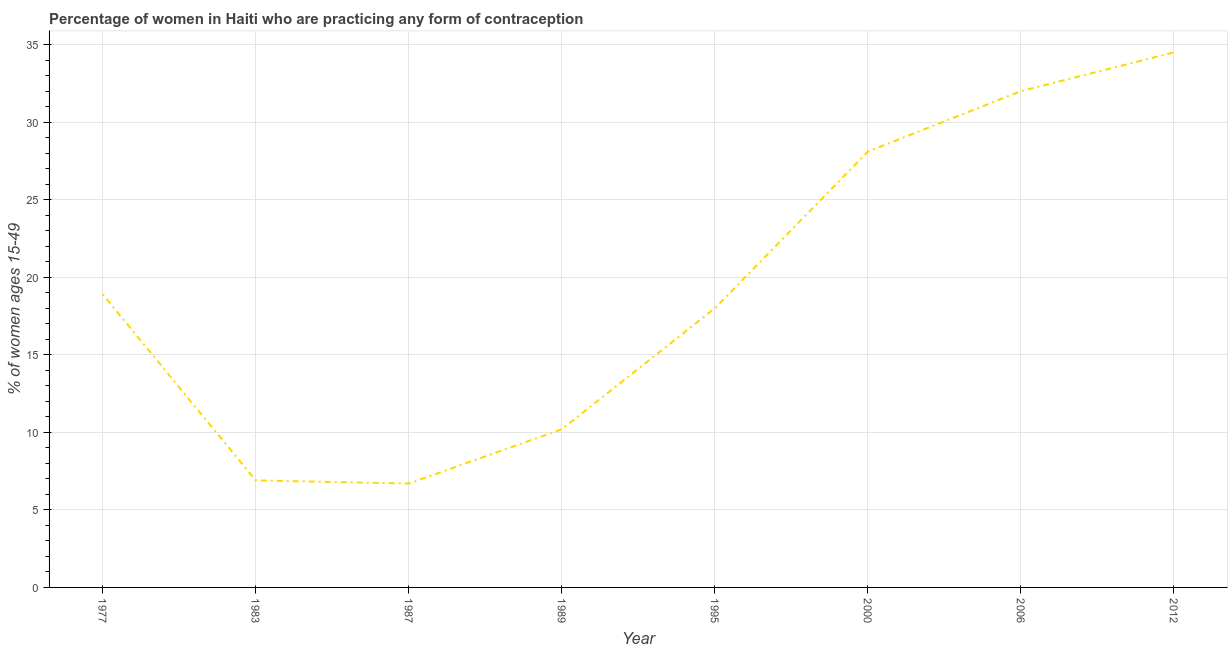What is the contraceptive prevalence in 2000?
Your answer should be compact. 28.1. Across all years, what is the maximum contraceptive prevalence?
Your response must be concise. 34.5. Across all years, what is the minimum contraceptive prevalence?
Your response must be concise. 6.7. In which year was the contraceptive prevalence maximum?
Your response must be concise. 2012. What is the sum of the contraceptive prevalence?
Keep it short and to the point. 155.3. What is the difference between the contraceptive prevalence in 1989 and 2006?
Give a very brief answer. -21.8. What is the average contraceptive prevalence per year?
Your answer should be very brief. 19.41. What is the median contraceptive prevalence?
Your answer should be very brief. 18.45. What is the ratio of the contraceptive prevalence in 1983 to that in 2006?
Provide a succinct answer. 0.22. Is the difference between the contraceptive prevalence in 1989 and 1995 greater than the difference between any two years?
Your answer should be very brief. No. Is the sum of the contraceptive prevalence in 1977 and 1989 greater than the maximum contraceptive prevalence across all years?
Keep it short and to the point. No. What is the difference between the highest and the lowest contraceptive prevalence?
Keep it short and to the point. 27.8. How many lines are there?
Ensure brevity in your answer.  1. Are the values on the major ticks of Y-axis written in scientific E-notation?
Your response must be concise. No. Does the graph contain grids?
Your response must be concise. Yes. What is the title of the graph?
Provide a succinct answer. Percentage of women in Haiti who are practicing any form of contraception. What is the label or title of the X-axis?
Provide a succinct answer. Year. What is the label or title of the Y-axis?
Give a very brief answer. % of women ages 15-49. What is the % of women ages 15-49 in 1983?
Your answer should be compact. 6.9. What is the % of women ages 15-49 of 1995?
Give a very brief answer. 18. What is the % of women ages 15-49 in 2000?
Your response must be concise. 28.1. What is the % of women ages 15-49 of 2006?
Ensure brevity in your answer.  32. What is the % of women ages 15-49 in 2012?
Make the answer very short. 34.5. What is the difference between the % of women ages 15-49 in 1977 and 2006?
Provide a short and direct response. -13.1. What is the difference between the % of women ages 15-49 in 1977 and 2012?
Provide a succinct answer. -15.6. What is the difference between the % of women ages 15-49 in 1983 and 1989?
Provide a short and direct response. -3.3. What is the difference between the % of women ages 15-49 in 1983 and 1995?
Your response must be concise. -11.1. What is the difference between the % of women ages 15-49 in 1983 and 2000?
Your response must be concise. -21.2. What is the difference between the % of women ages 15-49 in 1983 and 2006?
Your answer should be very brief. -25.1. What is the difference between the % of women ages 15-49 in 1983 and 2012?
Your response must be concise. -27.6. What is the difference between the % of women ages 15-49 in 1987 and 1989?
Give a very brief answer. -3.5. What is the difference between the % of women ages 15-49 in 1987 and 1995?
Provide a short and direct response. -11.3. What is the difference between the % of women ages 15-49 in 1987 and 2000?
Your answer should be compact. -21.4. What is the difference between the % of women ages 15-49 in 1987 and 2006?
Ensure brevity in your answer.  -25.3. What is the difference between the % of women ages 15-49 in 1987 and 2012?
Ensure brevity in your answer.  -27.8. What is the difference between the % of women ages 15-49 in 1989 and 2000?
Your answer should be very brief. -17.9. What is the difference between the % of women ages 15-49 in 1989 and 2006?
Give a very brief answer. -21.8. What is the difference between the % of women ages 15-49 in 1989 and 2012?
Make the answer very short. -24.3. What is the difference between the % of women ages 15-49 in 1995 and 2012?
Provide a succinct answer. -16.5. What is the difference between the % of women ages 15-49 in 2006 and 2012?
Your answer should be very brief. -2.5. What is the ratio of the % of women ages 15-49 in 1977 to that in 1983?
Provide a short and direct response. 2.74. What is the ratio of the % of women ages 15-49 in 1977 to that in 1987?
Your response must be concise. 2.82. What is the ratio of the % of women ages 15-49 in 1977 to that in 1989?
Ensure brevity in your answer.  1.85. What is the ratio of the % of women ages 15-49 in 1977 to that in 2000?
Give a very brief answer. 0.67. What is the ratio of the % of women ages 15-49 in 1977 to that in 2006?
Your answer should be compact. 0.59. What is the ratio of the % of women ages 15-49 in 1977 to that in 2012?
Your answer should be compact. 0.55. What is the ratio of the % of women ages 15-49 in 1983 to that in 1987?
Your answer should be very brief. 1.03. What is the ratio of the % of women ages 15-49 in 1983 to that in 1989?
Make the answer very short. 0.68. What is the ratio of the % of women ages 15-49 in 1983 to that in 1995?
Provide a succinct answer. 0.38. What is the ratio of the % of women ages 15-49 in 1983 to that in 2000?
Your response must be concise. 0.25. What is the ratio of the % of women ages 15-49 in 1983 to that in 2006?
Offer a terse response. 0.22. What is the ratio of the % of women ages 15-49 in 1987 to that in 1989?
Your answer should be very brief. 0.66. What is the ratio of the % of women ages 15-49 in 1987 to that in 1995?
Offer a very short reply. 0.37. What is the ratio of the % of women ages 15-49 in 1987 to that in 2000?
Your answer should be very brief. 0.24. What is the ratio of the % of women ages 15-49 in 1987 to that in 2006?
Your answer should be compact. 0.21. What is the ratio of the % of women ages 15-49 in 1987 to that in 2012?
Ensure brevity in your answer.  0.19. What is the ratio of the % of women ages 15-49 in 1989 to that in 1995?
Keep it short and to the point. 0.57. What is the ratio of the % of women ages 15-49 in 1989 to that in 2000?
Offer a terse response. 0.36. What is the ratio of the % of women ages 15-49 in 1989 to that in 2006?
Offer a very short reply. 0.32. What is the ratio of the % of women ages 15-49 in 1989 to that in 2012?
Keep it short and to the point. 0.3. What is the ratio of the % of women ages 15-49 in 1995 to that in 2000?
Give a very brief answer. 0.64. What is the ratio of the % of women ages 15-49 in 1995 to that in 2006?
Your answer should be very brief. 0.56. What is the ratio of the % of women ages 15-49 in 1995 to that in 2012?
Your answer should be very brief. 0.52. What is the ratio of the % of women ages 15-49 in 2000 to that in 2006?
Offer a terse response. 0.88. What is the ratio of the % of women ages 15-49 in 2000 to that in 2012?
Your answer should be very brief. 0.81. What is the ratio of the % of women ages 15-49 in 2006 to that in 2012?
Offer a terse response. 0.93. 